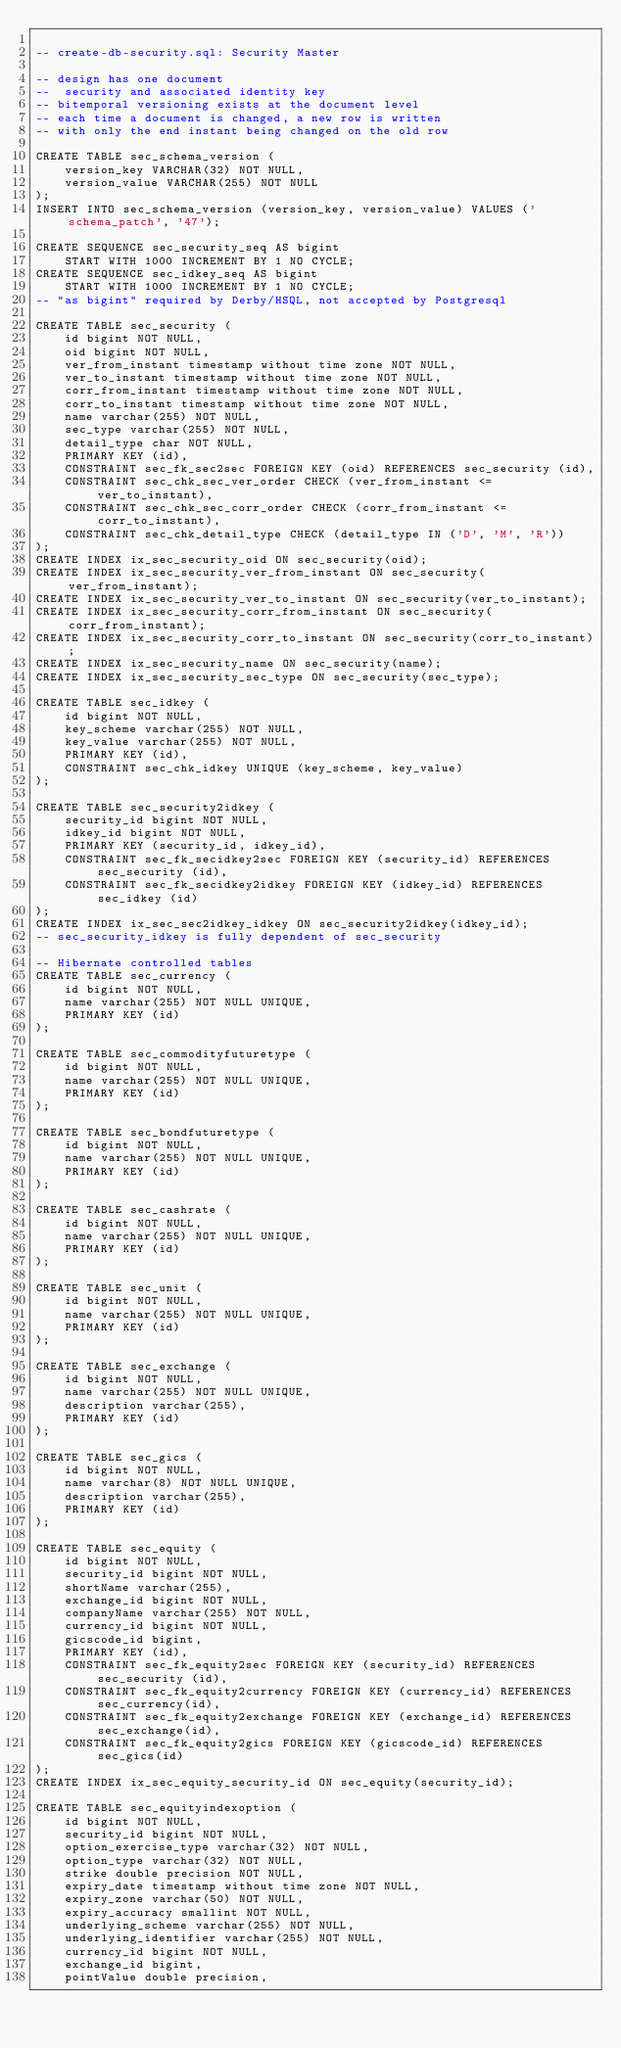Convert code to text. <code><loc_0><loc_0><loc_500><loc_500><_SQL_>
-- create-db-security.sql: Security Master

-- design has one document
--  security and associated identity key
-- bitemporal versioning exists at the document level
-- each time a document is changed, a new row is written
-- with only the end instant being changed on the old row

CREATE TABLE sec_schema_version (
    version_key VARCHAR(32) NOT NULL,
    version_value VARCHAR(255) NOT NULL
);
INSERT INTO sec_schema_version (version_key, version_value) VALUES ('schema_patch', '47');

CREATE SEQUENCE sec_security_seq AS bigint
    START WITH 1000 INCREMENT BY 1 NO CYCLE;
CREATE SEQUENCE sec_idkey_seq AS bigint
    START WITH 1000 INCREMENT BY 1 NO CYCLE;
-- "as bigint" required by Derby/HSQL, not accepted by Postgresql

CREATE TABLE sec_security (
    id bigint NOT NULL,
    oid bigint NOT NULL,
    ver_from_instant timestamp without time zone NOT NULL,
    ver_to_instant timestamp without time zone NOT NULL,
    corr_from_instant timestamp without time zone NOT NULL,
    corr_to_instant timestamp without time zone NOT NULL,
    name varchar(255) NOT NULL,
    sec_type varchar(255) NOT NULL,
    detail_type char NOT NULL,
    PRIMARY KEY (id),
    CONSTRAINT sec_fk_sec2sec FOREIGN KEY (oid) REFERENCES sec_security (id),
    CONSTRAINT sec_chk_sec_ver_order CHECK (ver_from_instant <= ver_to_instant),
    CONSTRAINT sec_chk_sec_corr_order CHECK (corr_from_instant <= corr_to_instant),
    CONSTRAINT sec_chk_detail_type CHECK (detail_type IN ('D', 'M', 'R'))
);
CREATE INDEX ix_sec_security_oid ON sec_security(oid);
CREATE INDEX ix_sec_security_ver_from_instant ON sec_security(ver_from_instant);
CREATE INDEX ix_sec_security_ver_to_instant ON sec_security(ver_to_instant);
CREATE INDEX ix_sec_security_corr_from_instant ON sec_security(corr_from_instant);
CREATE INDEX ix_sec_security_corr_to_instant ON sec_security(corr_to_instant);
CREATE INDEX ix_sec_security_name ON sec_security(name);
CREATE INDEX ix_sec_security_sec_type ON sec_security(sec_type);

CREATE TABLE sec_idkey (
    id bigint NOT NULL,
    key_scheme varchar(255) NOT NULL,
    key_value varchar(255) NOT NULL,
    PRIMARY KEY (id),
    CONSTRAINT sec_chk_idkey UNIQUE (key_scheme, key_value)
);

CREATE TABLE sec_security2idkey (
    security_id bigint NOT NULL,
    idkey_id bigint NOT NULL,
    PRIMARY KEY (security_id, idkey_id),
    CONSTRAINT sec_fk_secidkey2sec FOREIGN KEY (security_id) REFERENCES sec_security (id),
    CONSTRAINT sec_fk_secidkey2idkey FOREIGN KEY (idkey_id) REFERENCES sec_idkey (id)
);
CREATE INDEX ix_sec_sec2idkey_idkey ON sec_security2idkey(idkey_id);
-- sec_security_idkey is fully dependent of sec_security

-- Hibernate controlled tables
CREATE TABLE sec_currency (
    id bigint NOT NULL,
    name varchar(255) NOT NULL UNIQUE,
    PRIMARY KEY (id)
);

CREATE TABLE sec_commodityfuturetype (
    id bigint NOT NULL,
    name varchar(255) NOT NULL UNIQUE,
    PRIMARY KEY (id)
);

CREATE TABLE sec_bondfuturetype (
    id bigint NOT NULL,
    name varchar(255) NOT NULL UNIQUE,
    PRIMARY KEY (id)
);

CREATE TABLE sec_cashrate (
    id bigint NOT NULL,
    name varchar(255) NOT NULL UNIQUE,
    PRIMARY KEY (id)
);

CREATE TABLE sec_unit (
    id bigint NOT NULL,
    name varchar(255) NOT NULL UNIQUE,
    PRIMARY KEY (id)
);

CREATE TABLE sec_exchange (
    id bigint NOT NULL,
    name varchar(255) NOT NULL UNIQUE,
    description varchar(255),
    PRIMARY KEY (id)
);

CREATE TABLE sec_gics (
    id bigint NOT NULL,
    name varchar(8) NOT NULL UNIQUE,
    description varchar(255),
    PRIMARY KEY (id)
);

CREATE TABLE sec_equity (
    id bigint NOT NULL,
    security_id bigint NOT NULL,
    shortName varchar(255),
    exchange_id bigint NOT NULL,
    companyName varchar(255) NOT NULL,
    currency_id bigint NOT NULL,
    gicscode_id bigint,
    PRIMARY KEY (id),
    CONSTRAINT sec_fk_equity2sec FOREIGN KEY (security_id) REFERENCES sec_security (id),
    CONSTRAINT sec_fk_equity2currency FOREIGN KEY (currency_id) REFERENCES sec_currency(id),
    CONSTRAINT sec_fk_equity2exchange FOREIGN KEY (exchange_id) REFERENCES sec_exchange(id),
    CONSTRAINT sec_fk_equity2gics FOREIGN KEY (gicscode_id) REFERENCES sec_gics(id)
);
CREATE INDEX ix_sec_equity_security_id ON sec_equity(security_id);

CREATE TABLE sec_equityindexoption (
    id bigint NOT NULL,
    security_id bigint NOT NULL,
    option_exercise_type varchar(32) NOT NULL,
    option_type varchar(32) NOT NULL,
    strike double precision NOT NULL,
    expiry_date timestamp without time zone NOT NULL,
    expiry_zone varchar(50) NOT NULL,
    expiry_accuracy smallint NOT NULL,
    underlying_scheme varchar(255) NOT NULL,
    underlying_identifier varchar(255) NOT NULL,
    currency_id bigint NOT NULL,
    exchange_id bigint,
    pointValue double precision,</code> 